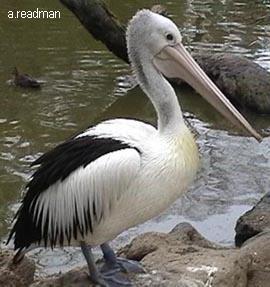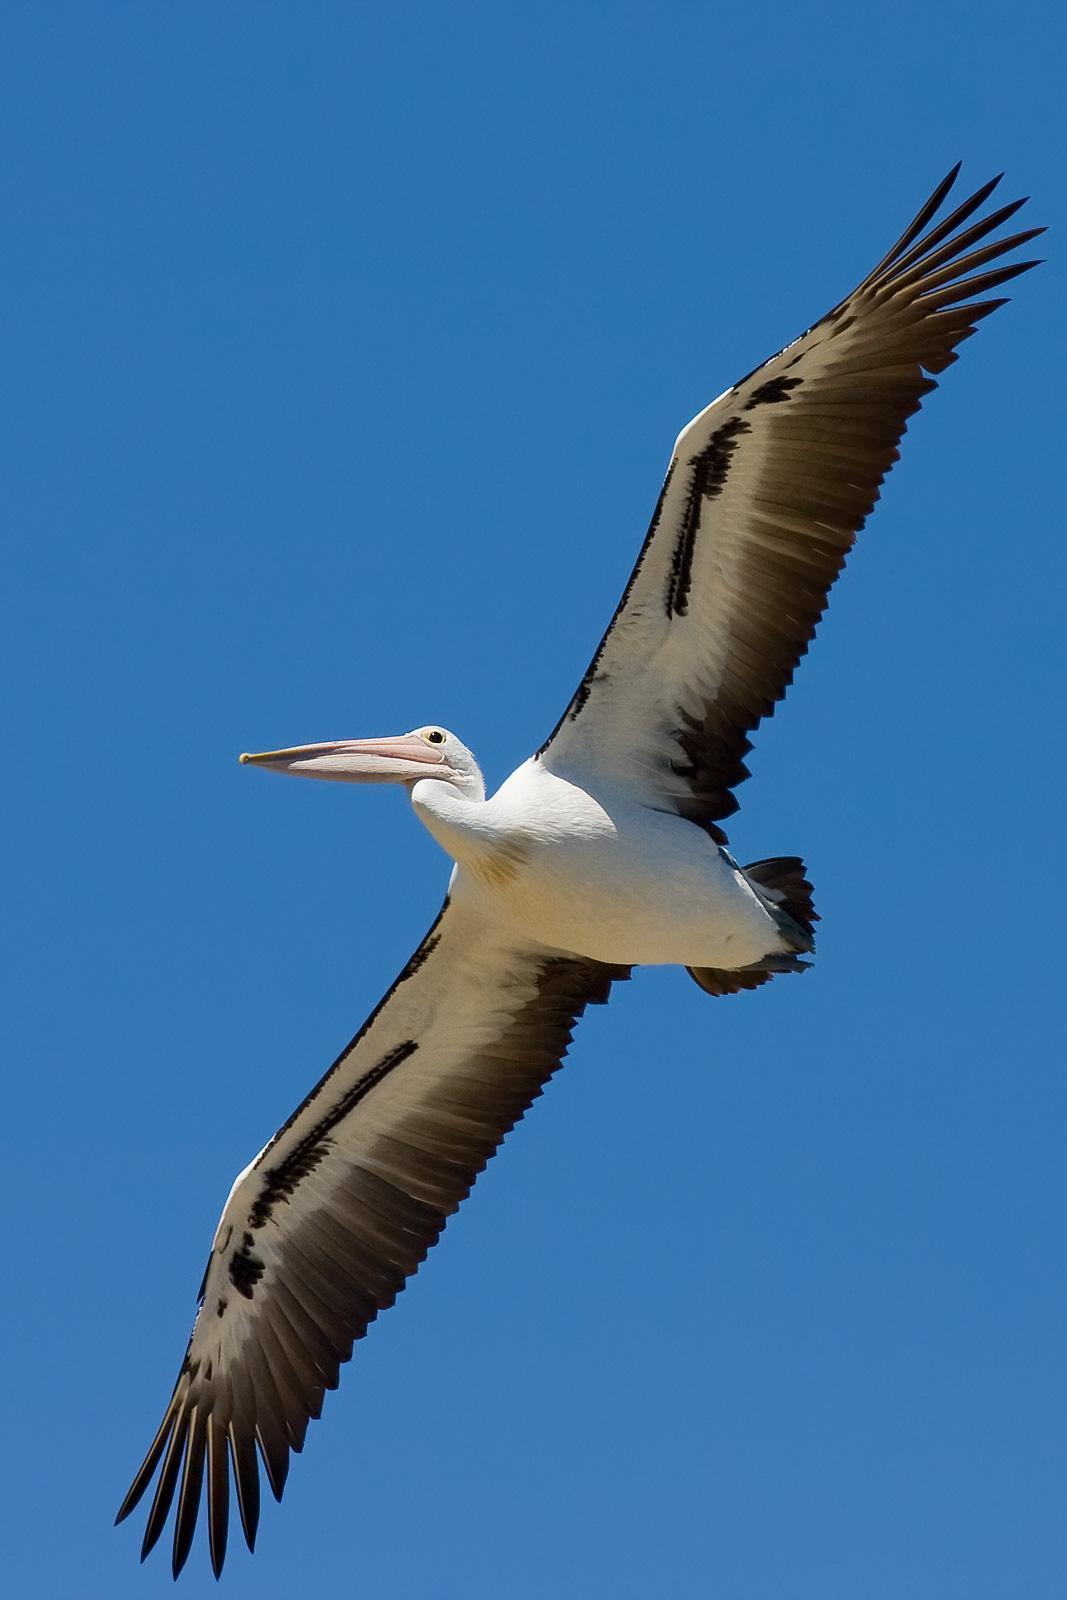The first image is the image on the left, the second image is the image on the right. Considering the images on both sides, is "There is a pelican flying in the air." valid? Answer yes or no. Yes. 